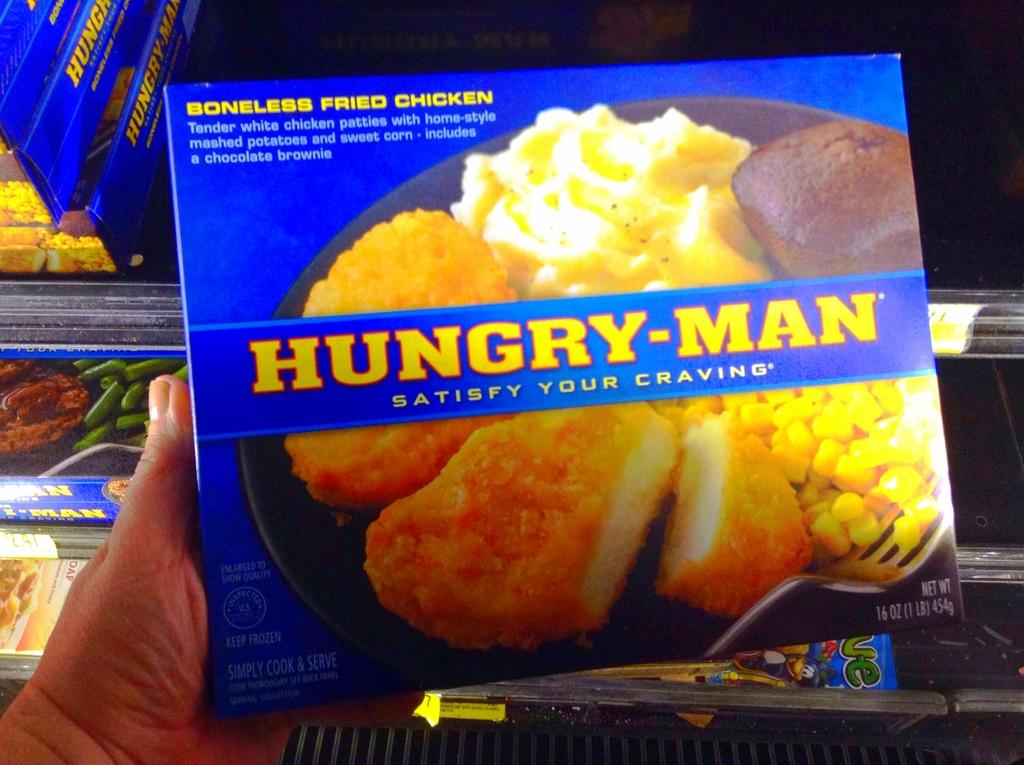What is being held by the person's hand in the image? There is a person's hand holding a carton in the image. What can be seen in the background of the image? There are shelves with cartons arranged in the background of the image. How many ducks are visible on the seashore in the image? There are no ducks or seashore present in the image; it features a person's hand holding a carton and shelves with cartons in the background. 